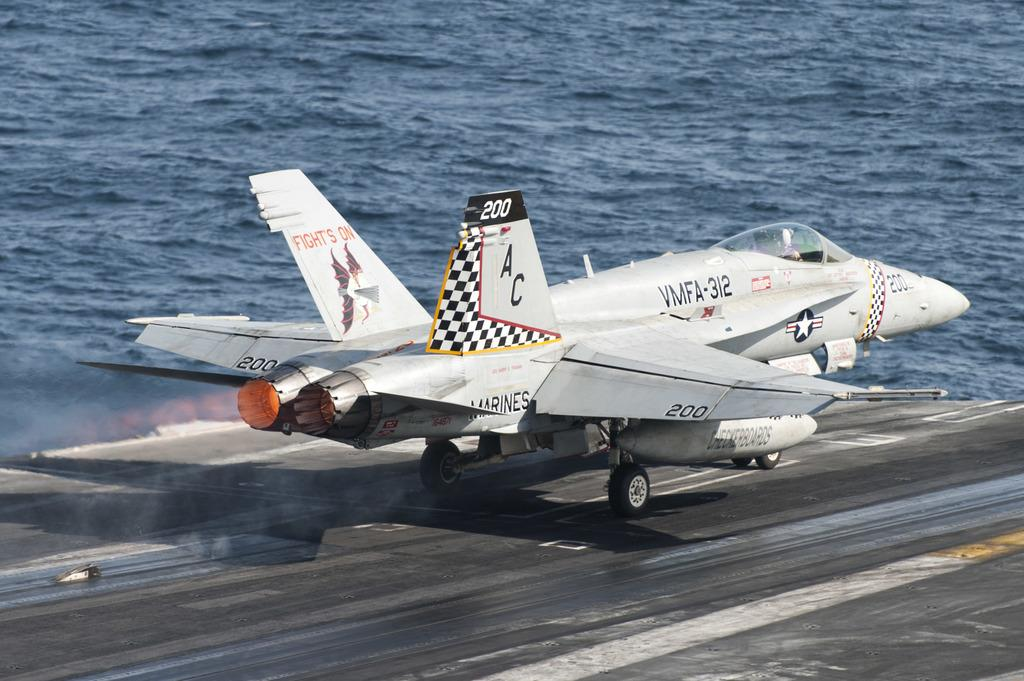<image>
Relay a brief, clear account of the picture shown. A fighter jet labeled VMFA-312 is taking off from a aircraft carrier. 